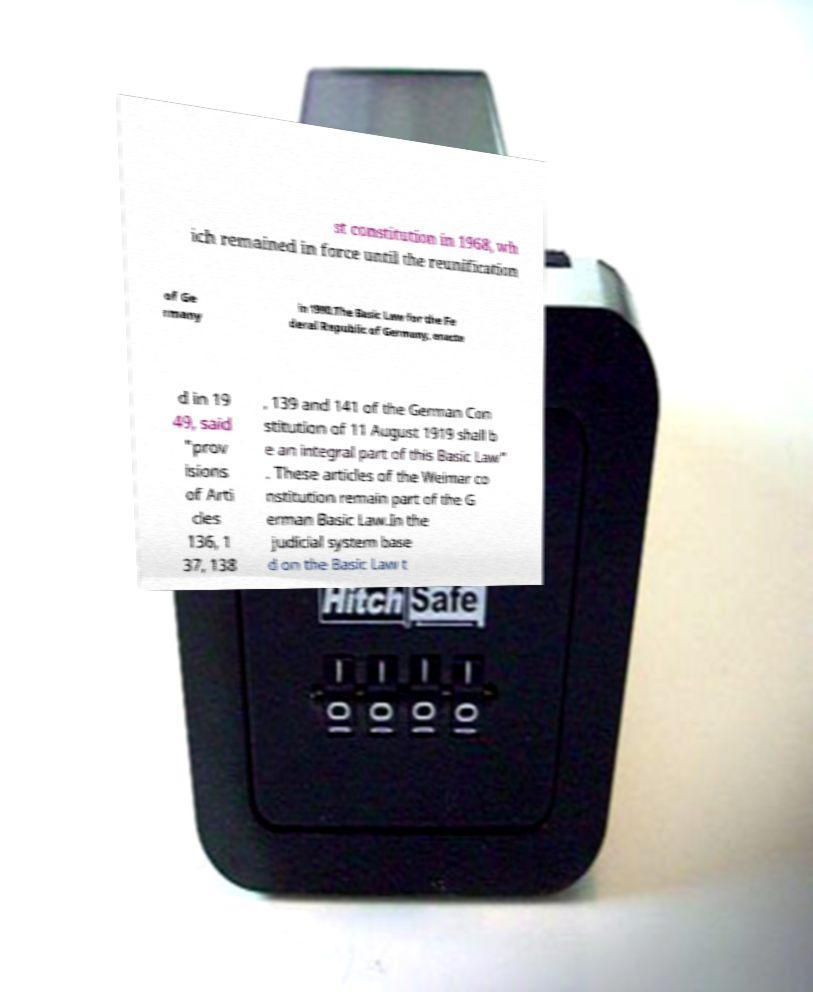I need the written content from this picture converted into text. Can you do that? st constitution in 1968, wh ich remained in force until the reunification of Ge rmany in 1990.The Basic Law for the Fe deral Republic of Germany, enacte d in 19 49, said "prov isions of Arti cles 136, 1 37, 138 , 139 and 141 of the German Con stitution of 11 August 1919 shall b e an integral part of this Basic Law" . These articles of the Weimar co nstitution remain part of the G erman Basic Law.In the judicial system base d on the Basic Law t 